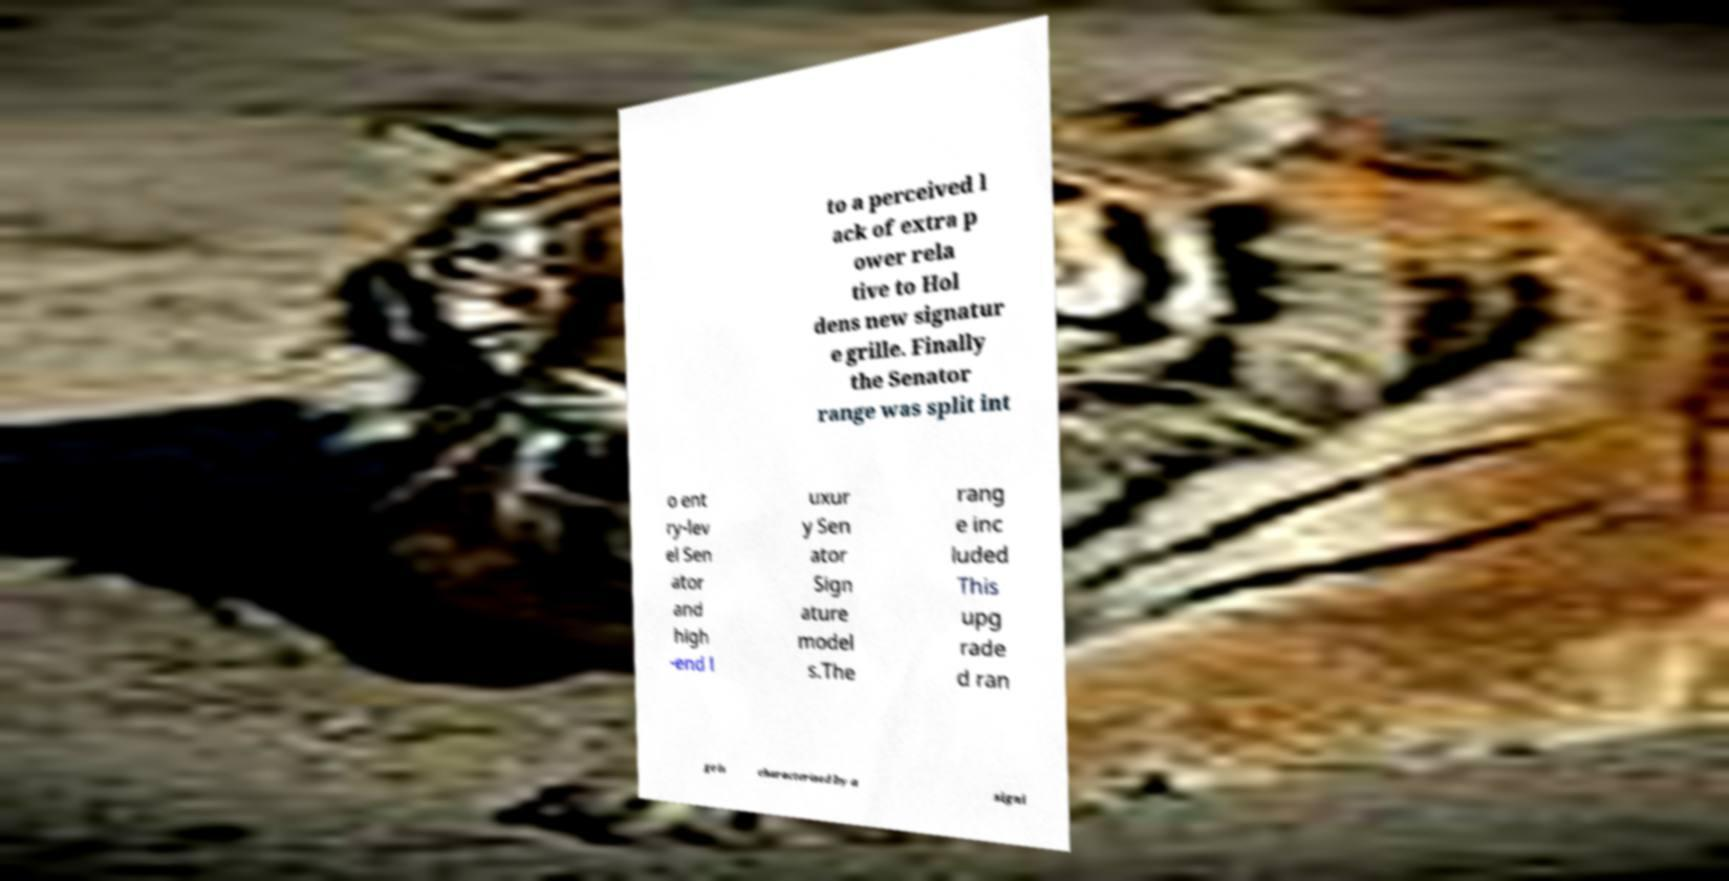Please read and relay the text visible in this image. What does it say? to a perceived l ack of extra p ower rela tive to Hol dens new signatur e grille. Finally the Senator range was split int o ent ry-lev el Sen ator and high -end l uxur y Sen ator Sign ature model s.The rang e inc luded This upg rade d ran ge is characterised by a signi 